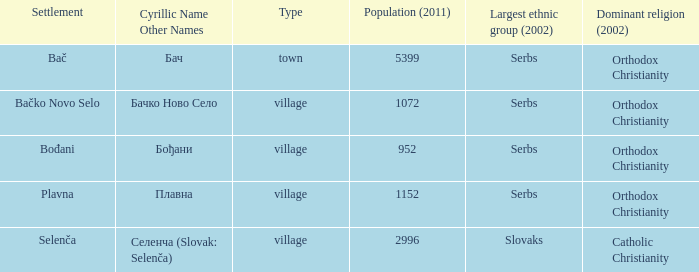What is the second approach to writing плавна? Plavna. 